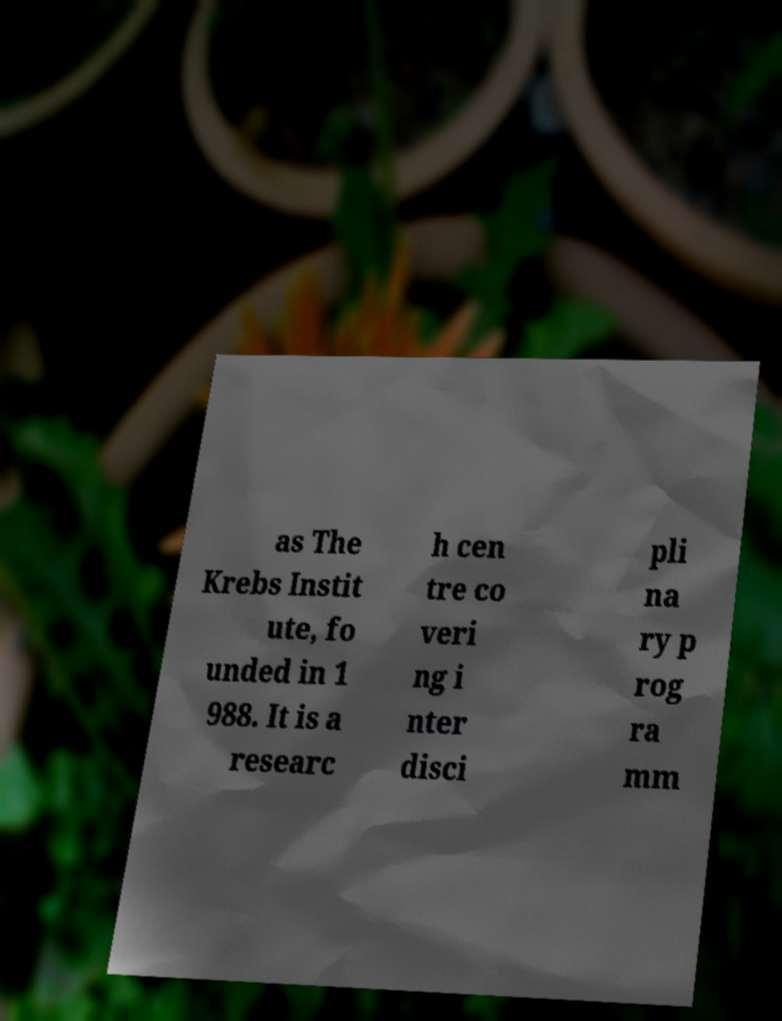For documentation purposes, I need the text within this image transcribed. Could you provide that? as The Krebs Instit ute, fo unded in 1 988. It is a researc h cen tre co veri ng i nter disci pli na ry p rog ra mm 